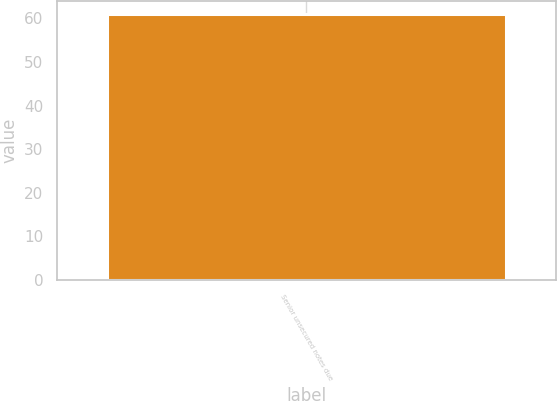<chart> <loc_0><loc_0><loc_500><loc_500><bar_chart><fcel>Senior unsecured notes due<nl><fcel>61<nl></chart> 